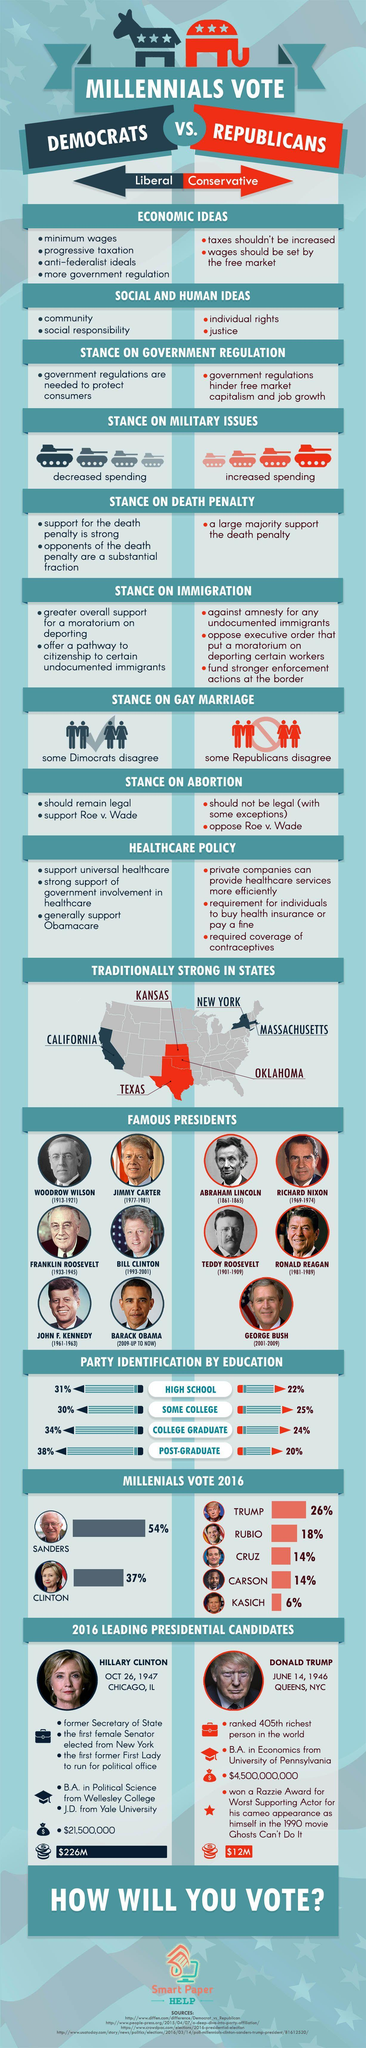When was Donald Trump born?
Answer the question with a short phrase. JUNE 14, 1946 During which period Abraham Lincoln served as the U.S. president? (1861-1865) Who served as the US president during 2001-2009? GEORGE BUSH What percentage of millennials voted for Hillary Clinton in 2016? 37% Where was Hillary Clinton born? CHICAGO, IL In which U.S. states, the Republican party is traditionally strong? KANSAS, TEXAS, OKLAHOMA 